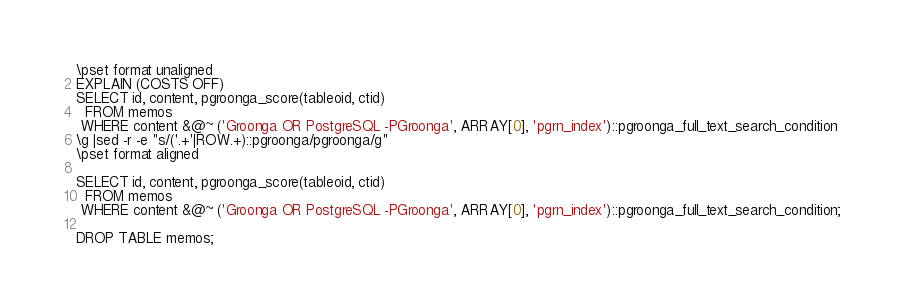Convert code to text. <code><loc_0><loc_0><loc_500><loc_500><_SQL_>\pset format unaligned
EXPLAIN (COSTS OFF)
SELECT id, content, pgroonga_score(tableoid, ctid)
  FROM memos
 WHERE content &@~ ('Groonga OR PostgreSQL -PGroonga', ARRAY[0], 'pgrn_index')::pgroonga_full_text_search_condition
\g |sed -r -e "s/('.+'|ROW.+)::pgroonga/pgroonga/g"
\pset format aligned

SELECT id, content, pgroonga_score(tableoid, ctid)
  FROM memos
 WHERE content &@~ ('Groonga OR PostgreSQL -PGroonga', ARRAY[0], 'pgrn_index')::pgroonga_full_text_search_condition;

DROP TABLE memos;
</code> 